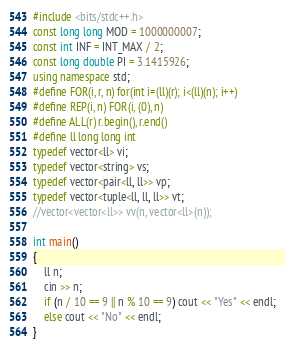<code> <loc_0><loc_0><loc_500><loc_500><_C++_>#include <bits/stdc++.h>
const long long MOD = 1000000007;
const int INF = INT_MAX / 2;
const long double PI = 3.1415926;
using namespace std;
#define FOR(i, r, n) for(int i=(ll)(r); i<(ll)(n); i++) 
#define REP(i, n) FOR(i, (0), n)
#define ALL(r) r.begin(), r.end()
#define ll long long int
typedef vector<ll> vi;
typedef vector<string> vs;
typedef vector<pair<ll, ll>> vp;
typedef vector<tuple<ll, ll, ll>> vt;
//vector<vector<ll>> vv(n, vector<ll>(n));

int main()
{
	ll n;
	cin >> n;
	if (n / 10 == 9 || n % 10 == 9) cout << "Yes" << endl;
	else cout << "No" << endl;
}</code> 